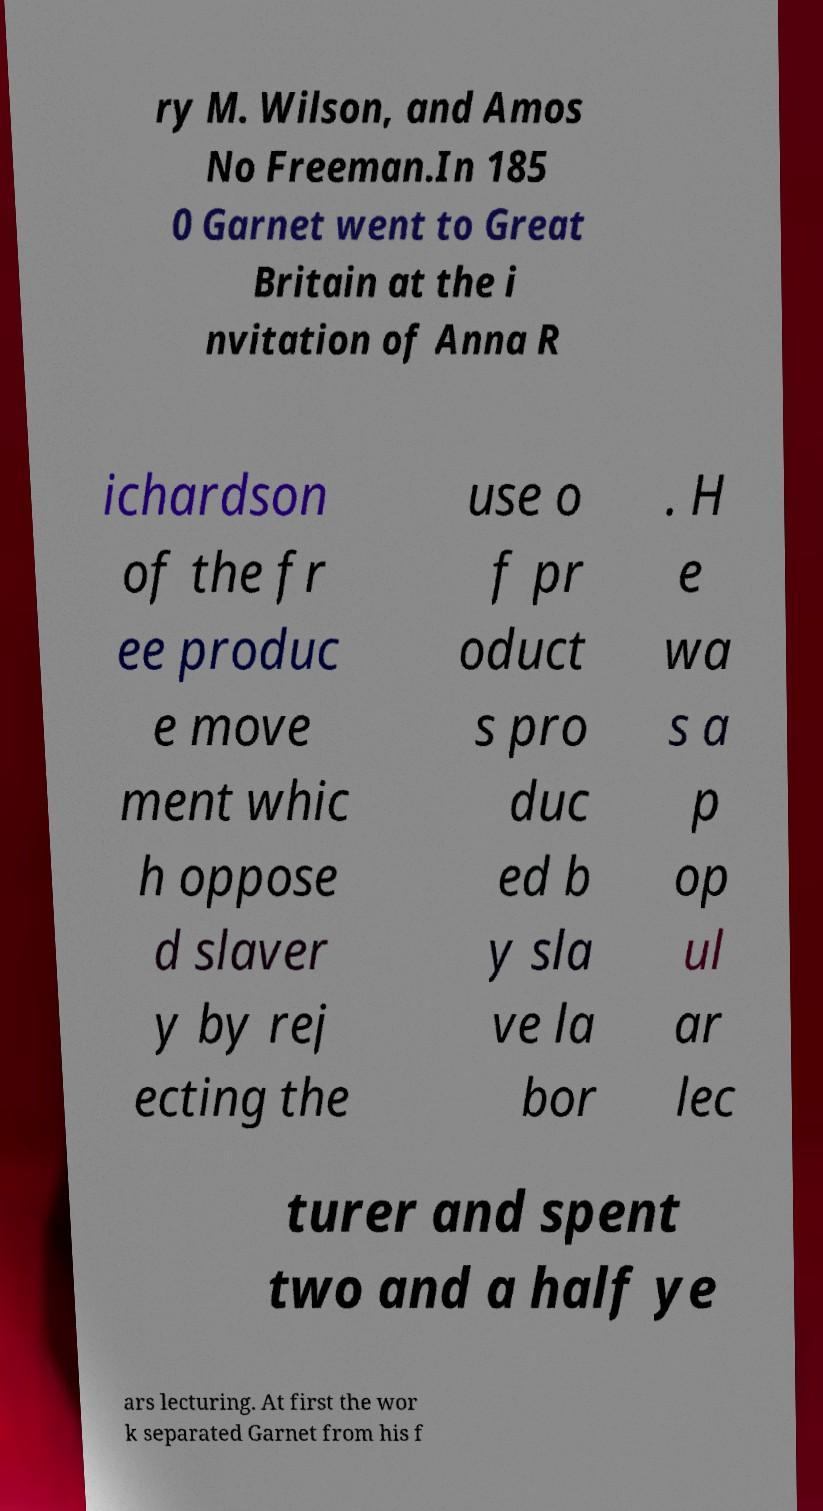Could you extract and type out the text from this image? ry M. Wilson, and Amos No Freeman.In 185 0 Garnet went to Great Britain at the i nvitation of Anna R ichardson of the fr ee produc e move ment whic h oppose d slaver y by rej ecting the use o f pr oduct s pro duc ed b y sla ve la bor . H e wa s a p op ul ar lec turer and spent two and a half ye ars lecturing. At first the wor k separated Garnet from his f 